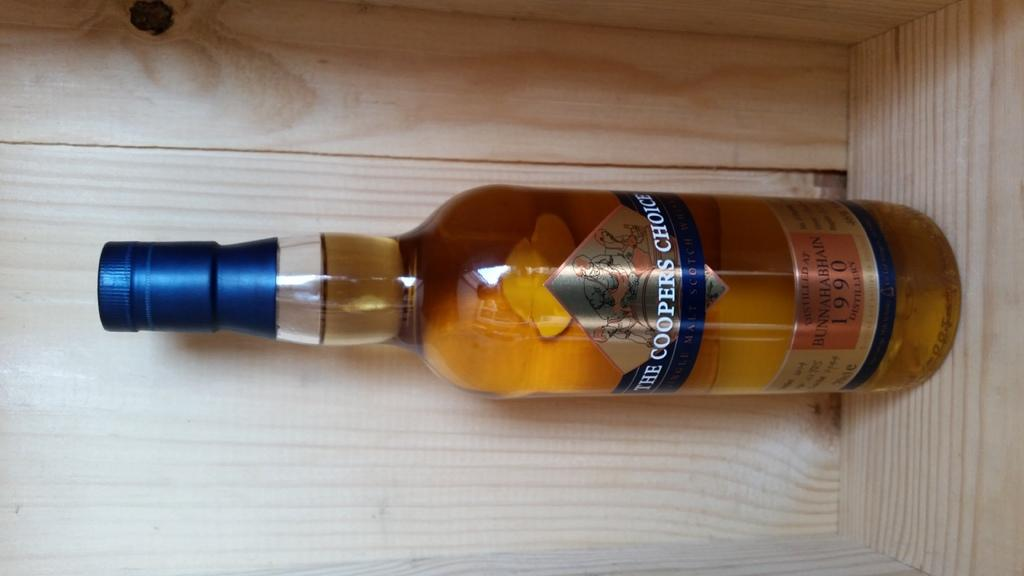<image>
Give a short and clear explanation of the subsequent image. A bottle of The Cooper's Choice whiskey is on a wooden shelf. 